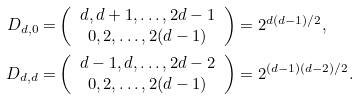Convert formula to latex. <formula><loc_0><loc_0><loc_500><loc_500>D _ { d , 0 } = & \left ( \begin{array} { c } d , d + 1 , \dots , 2 d - 1 \\ 0 , 2 , \dots , 2 ( d - 1 ) \\ \end{array} \right ) = 2 ^ { d ( d - 1 ) / 2 } , \\ D _ { d , d } = & \left ( \begin{array} { c } d - 1 , d , \dots , 2 d - 2 \\ 0 , 2 , \dots , 2 ( d - 1 ) \\ \end{array} \right ) = 2 ^ { ( d - 1 ) ( d - 2 ) / 2 } .</formula> 